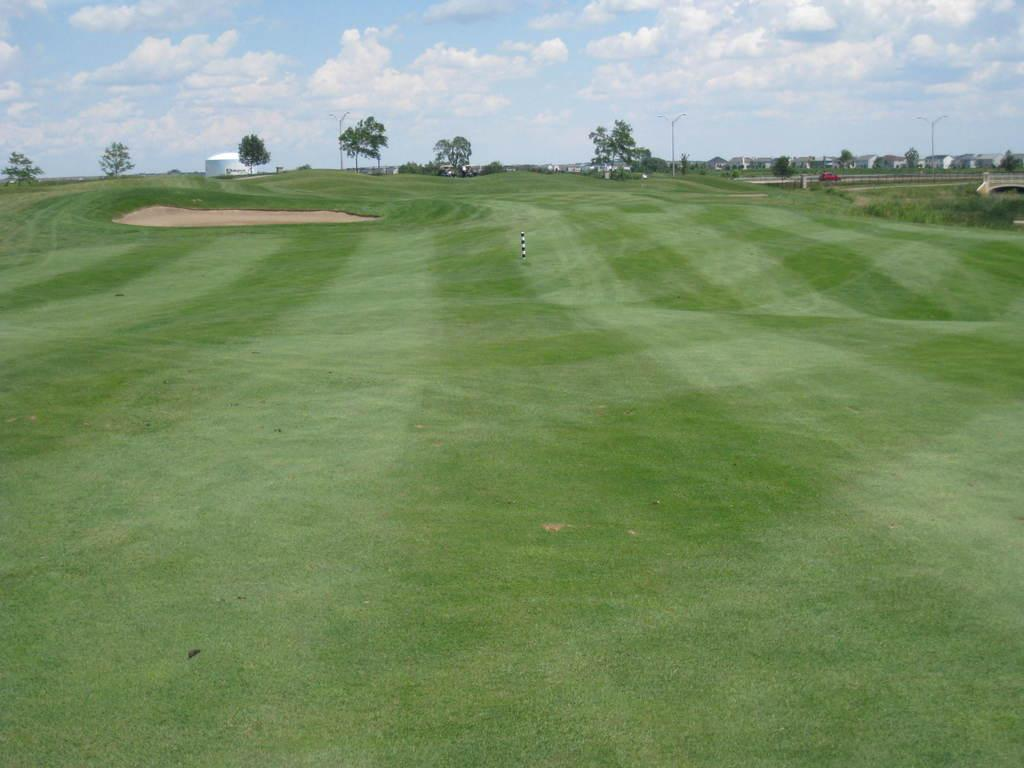What type of vegetation is present on the ground in the front of the image? There is grass on the ground in the front of the image. What can be seen in the background of the image? There are trees and buildings in the background of the image. What is the condition of the sky in the image? The sky is cloudy in the image. Who is the owner of the shoes seen in the image? There are no shoes present in the image, so it is not possible to determine the owner. 